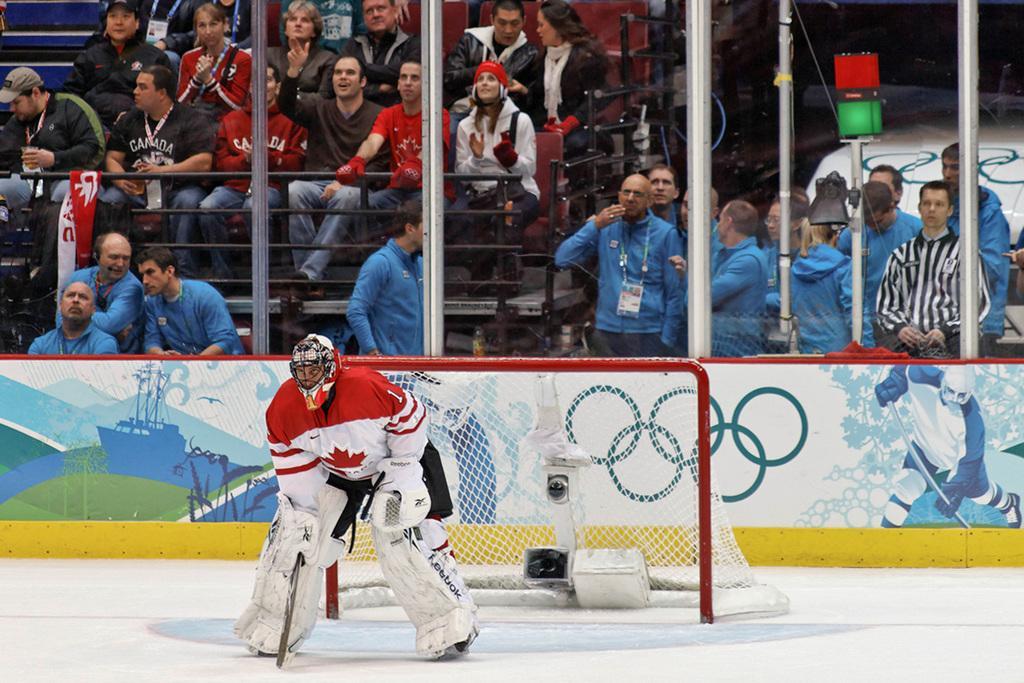How would you summarize this image in a sentence or two? Here in this picture we can see a person standing on the ice floor and we can see he is wearing skates, pads, gloves and helmet and behind him we can see a goal post with net on it and behind that we can see number of people sitting and standing in the stands and we can see a glass wall present in the front. 